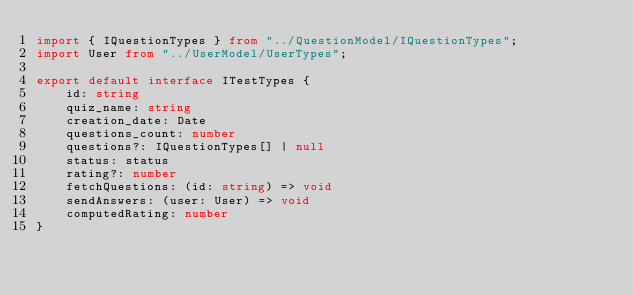<code> <loc_0><loc_0><loc_500><loc_500><_TypeScript_>import { IQuestionTypes } from "../QuestionModel/IQuestionTypes";
import User from "../UserModel/UserTypes";

export default interface ITestTypes {
    id: string
    quiz_name: string
    creation_date: Date
    questions_count: number
    questions?: IQuestionTypes[] | null
    status: status
    rating?: number
    fetchQuestions: (id: string) => void
    sendAnswers: (user: User) => void
    computedRating: number
}</code> 